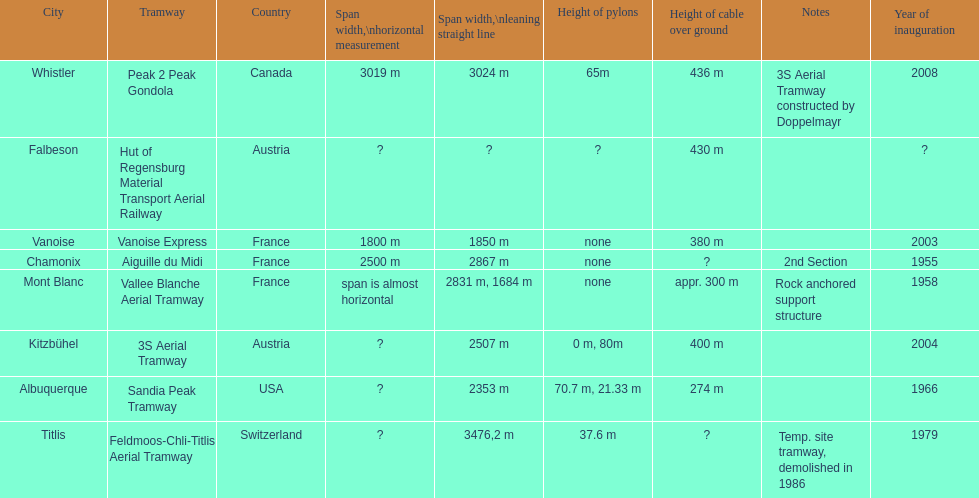At least how many aerial tramways were inaugurated after 1970? 4. 